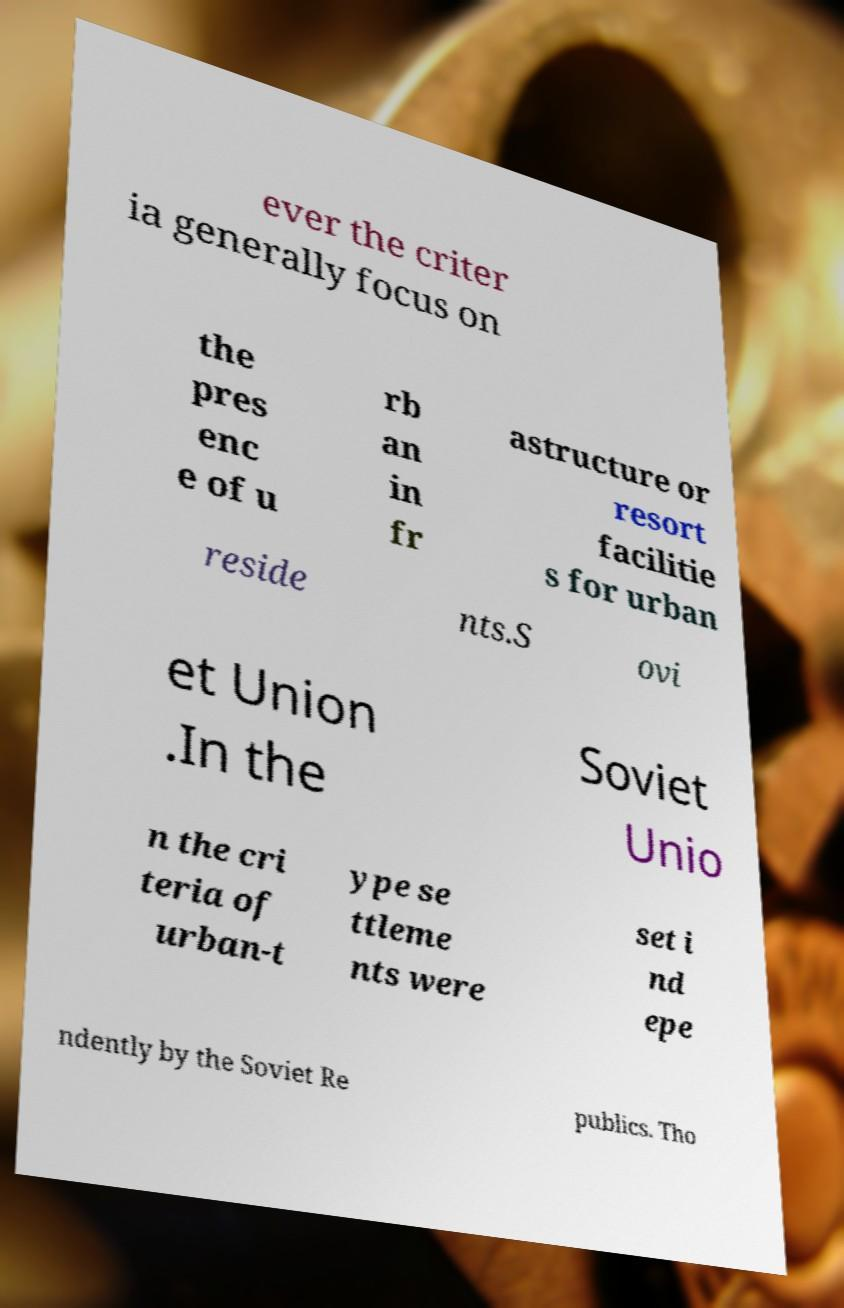Please identify and transcribe the text found in this image. ever the criter ia generally focus on the pres enc e of u rb an in fr astructure or resort facilitie s for urban reside nts.S ovi et Union .In the Soviet Unio n the cri teria of urban-t ype se ttleme nts were set i nd epe ndently by the Soviet Re publics. Tho 